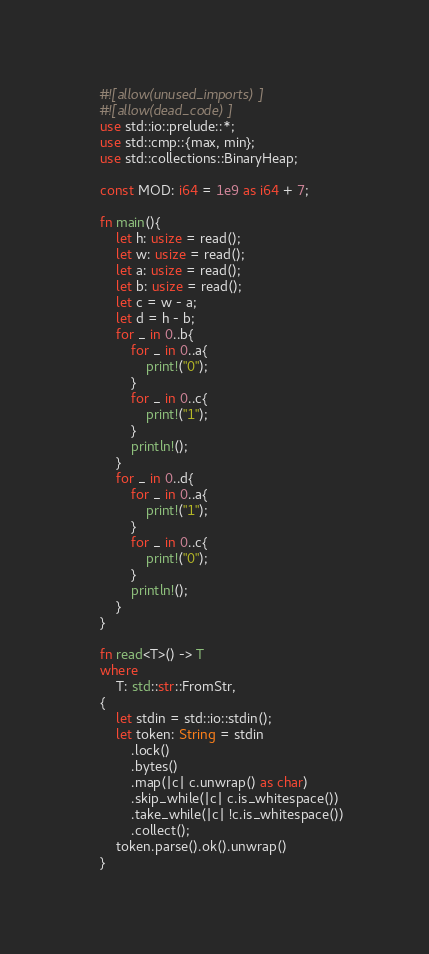Convert code to text. <code><loc_0><loc_0><loc_500><loc_500><_Rust_>    #![allow(unused_imports)]
    #![allow(dead_code)]
    use std::io::prelude::*;
    use std::cmp::{max, min};
    use std::collections::BinaryHeap;

    const MOD: i64 = 1e9 as i64 + 7; 

    fn main(){
        let h: usize = read();
        let w: usize = read();
        let a: usize = read();
        let b: usize = read();
        let c = w - a;
        let d = h - b;
        for _ in 0..b{
            for _ in 0..a{
                print!("0");
            }
            for _ in 0..c{
                print!("1");
            }
            println!();
        }
        for _ in 0..d{
            for _ in 0..a{
                print!("1");
            }
            for _ in 0..c{
                print!("0");
            }
            println!();
        }
    }

    fn read<T>() -> T
    where
        T: std::str::FromStr,
    {
        let stdin = std::io::stdin();
        let token: String = stdin
            .lock()
            .bytes()
            .map(|c| c.unwrap() as char)
            .skip_while(|c| c.is_whitespace())
            .take_while(|c| !c.is_whitespace())
            .collect();
        token.parse().ok().unwrap()
    }
</code> 